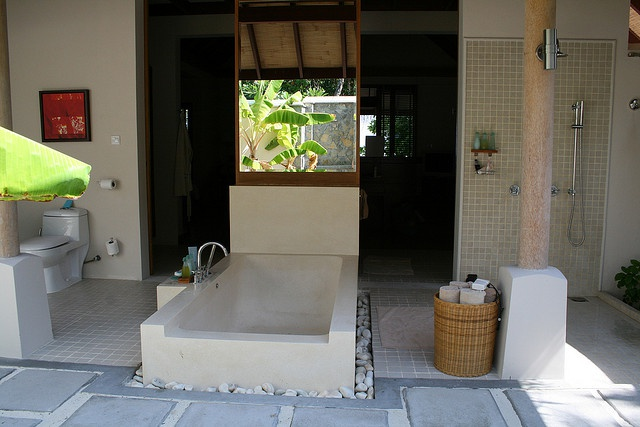Describe the objects in this image and their specific colors. I can see umbrella in black, khaki, green, and lightgreen tones, toilet in black and gray tones, potted plant in black and gray tones, bottle in black, gray, and teal tones, and bottle in black, darkgreen, and gray tones in this image. 